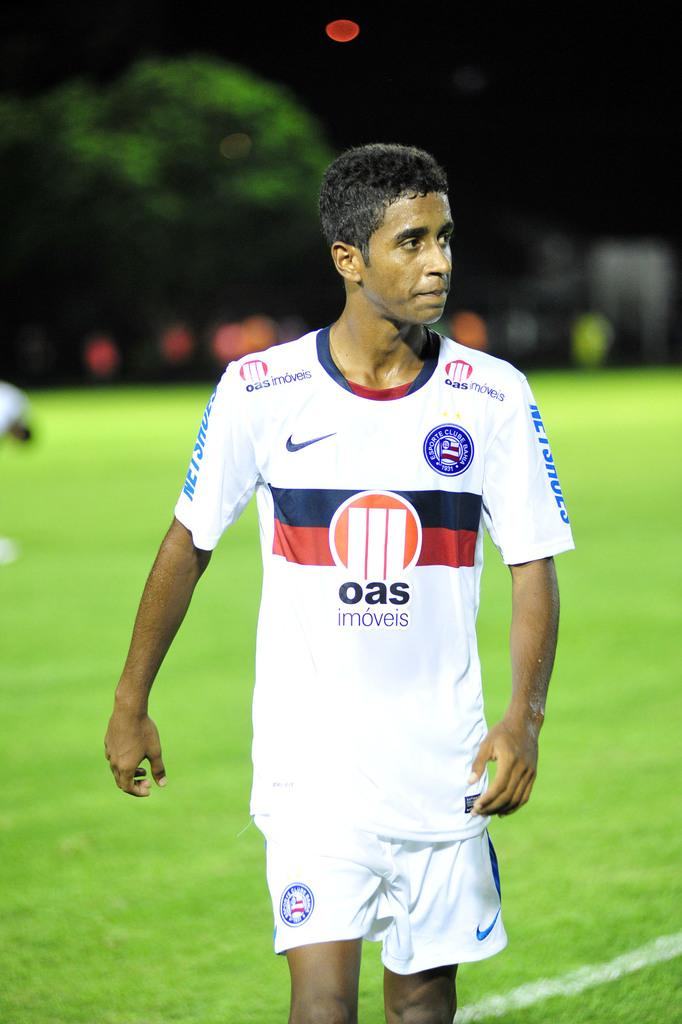<image>
Relay a brief, clear account of the picture shown. A man in a shirt that says oas imoveis on it walks across the green field. 